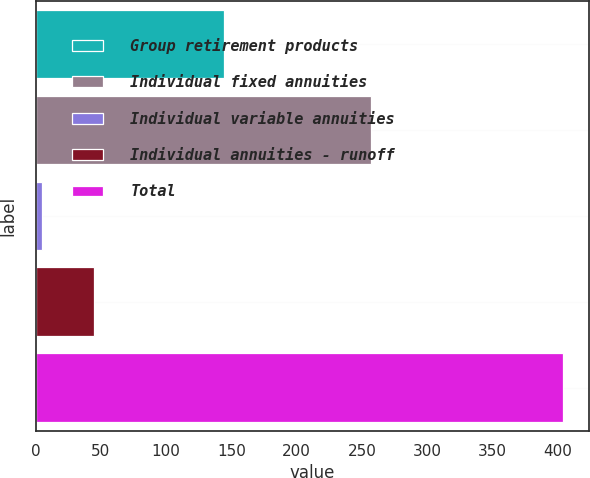Convert chart to OTSL. <chart><loc_0><loc_0><loc_500><loc_500><bar_chart><fcel>Group retirement products<fcel>Individual fixed annuities<fcel>Individual variable annuities<fcel>Individual annuities - runoff<fcel>Total<nl><fcel>144<fcel>257<fcel>5<fcel>44.9<fcel>404<nl></chart> 